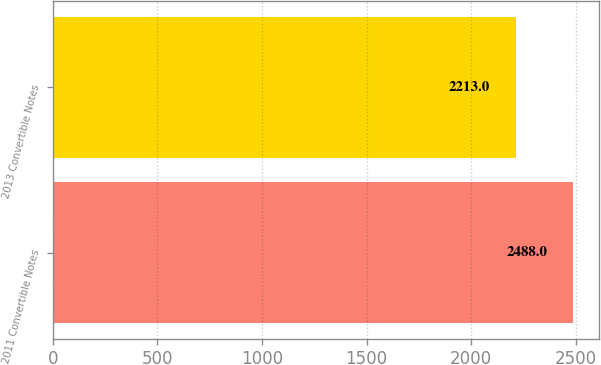<chart> <loc_0><loc_0><loc_500><loc_500><bar_chart><fcel>2011 Convertible Notes<fcel>2013 Convertible Notes<nl><fcel>2488<fcel>2213<nl></chart> 